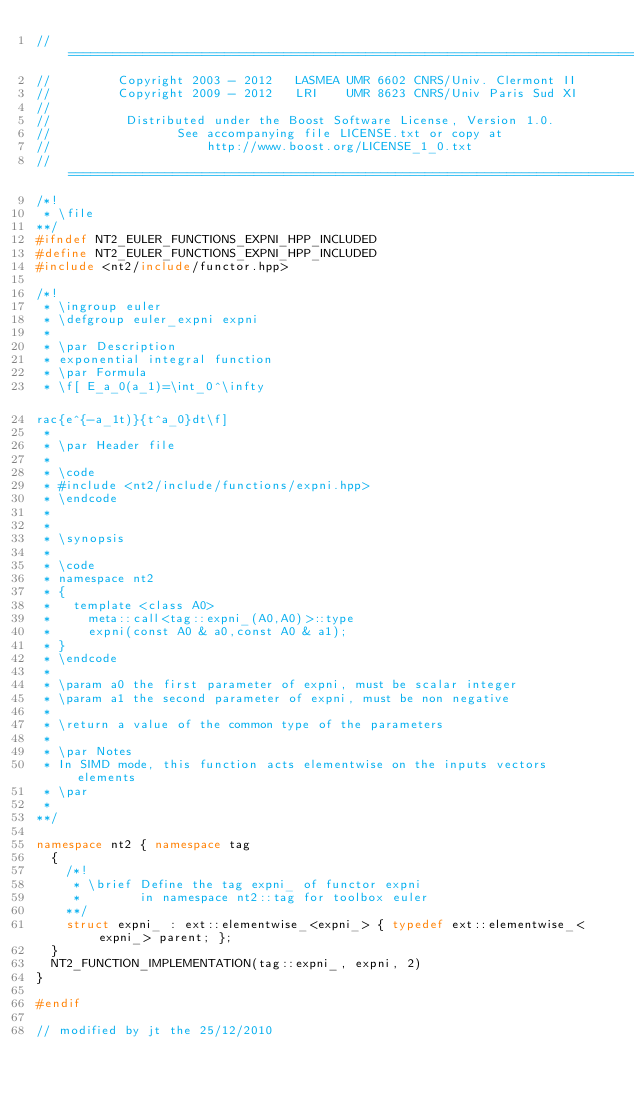Convert code to text. <code><loc_0><loc_0><loc_500><loc_500><_C++_>//==============================================================================
//         Copyright 2003 - 2012   LASMEA UMR 6602 CNRS/Univ. Clermont II
//         Copyright 2009 - 2012   LRI    UMR 8623 CNRS/Univ Paris Sud XI
//
//          Distributed under the Boost Software License, Version 1.0.
//                 See accompanying file LICENSE.txt or copy at
//                     http://www.boost.org/LICENSE_1_0.txt
//==============================================================================
/*!
 * \file
**/
#ifndef NT2_EULER_FUNCTIONS_EXPNI_HPP_INCLUDED
#define NT2_EULER_FUNCTIONS_EXPNI_HPP_INCLUDED
#include <nt2/include/functor.hpp>

/*!
 * \ingroup euler
 * \defgroup euler_expni expni
 *
 * \par Description
 * exponential integral function
 * \par Formula
 * \f[ E_a_0(a_1)=\int_0^\infty rac{e^{-a_1t)}{t^a_0}dt\f]
 *
 * \par Header file
 *
 * \code
 * #include <nt2/include/functions/expni.hpp>
 * \endcode
 *
 *
 * \synopsis
 *
 * \code
 * namespace nt2
 * {
 *   template <class A0>
 *     meta::call<tag::expni_(A0,A0)>::type
 *     expni(const A0 & a0,const A0 & a1);
 * }
 * \endcode
 *
 * \param a0 the first parameter of expni, must be scalar integer
 * \param a1 the second parameter of expni, must be non negative
 *
 * \return a value of the common type of the parameters
 *
 * \par Notes
 * In SIMD mode, this function acts elementwise on the inputs vectors elements
 * \par
 *
**/

namespace nt2 { namespace tag
  {
    /*!
     * \brief Define the tag expni_ of functor expni
     *        in namespace nt2::tag for toolbox euler
    **/
    struct expni_ : ext::elementwise_<expni_> { typedef ext::elementwise_<expni_> parent; };
  }
  NT2_FUNCTION_IMPLEMENTATION(tag::expni_, expni, 2)
}

#endif

// modified by jt the 25/12/2010
</code> 